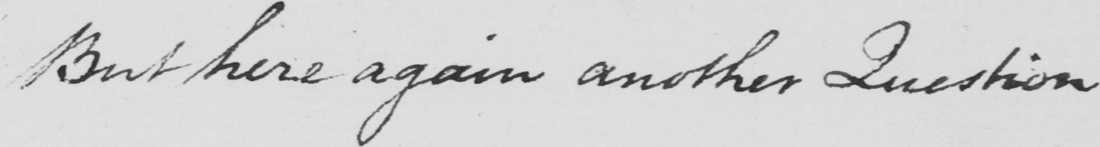What does this handwritten line say? But here again another Question 